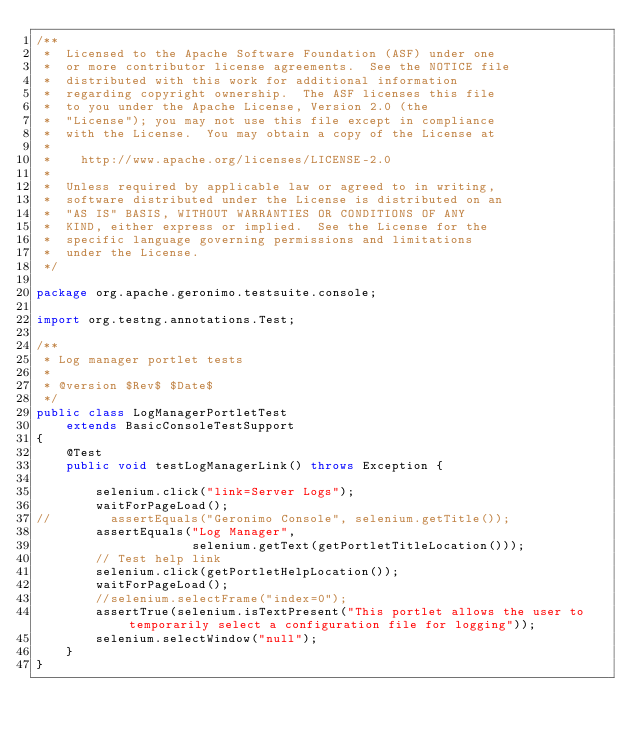<code> <loc_0><loc_0><loc_500><loc_500><_Java_>/**
 *  Licensed to the Apache Software Foundation (ASF) under one
 *  or more contributor license agreements.  See the NOTICE file
 *  distributed with this work for additional information
 *  regarding copyright ownership.  The ASF licenses this file
 *  to you under the Apache License, Version 2.0 (the
 *  "License"); you may not use this file except in compliance
 *  with the License.  You may obtain a copy of the License at
 *
 *    http://www.apache.org/licenses/LICENSE-2.0
 *
 *  Unless required by applicable law or agreed to in writing,
 *  software distributed under the License is distributed on an
 *  "AS IS" BASIS, WITHOUT WARRANTIES OR CONDITIONS OF ANY
 *  KIND, either express or implied.  See the License for the
 *  specific language governing permissions and limitations
 *  under the License.
 */

package org.apache.geronimo.testsuite.console;

import org.testng.annotations.Test;

/**
 * Log manager portlet tests
 *
 * @version $Rev$ $Date$
 */
public class LogManagerPortletTest
    extends BasicConsoleTestSupport
{
    @Test
    public void testLogManagerLink() throws Exception {
    	
        selenium.click("link=Server Logs");
        waitForPageLoad();
//        assertEquals("Geronimo Console", selenium.getTitle());
        assertEquals("Log Manager", 
                     selenium.getText(getPortletTitleLocation())); 
        // Test help link
        selenium.click(getPortletHelpLocation());
        waitForPageLoad();
        //selenium.selectFrame("index=0");
        assertTrue(selenium.isTextPresent("This portlet allows the user to temporarily select a configuration file for logging"));
        selenium.selectWindow("null");
    }
}
</code> 